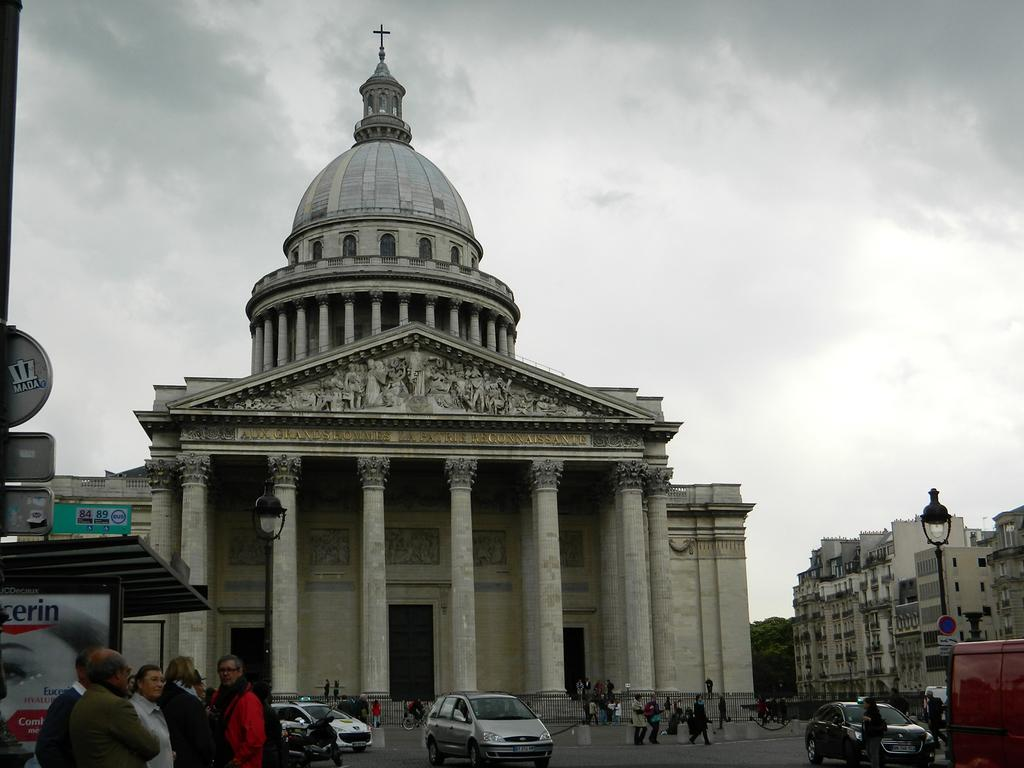What can be seen in the left corner of the image? There are persons standing in the left corner of the image. What is located near the persons? There are vehicles beside the persons. What type of structures are visible in the background of the image? There are buildings in the background of the image. How would you describe the sky in the image? The sky is cloudy in the image. What type of bath can be seen in the image? There is no bath present in the image. What color is the straw that the persons are holding in the image? There is no straw present in the image. 